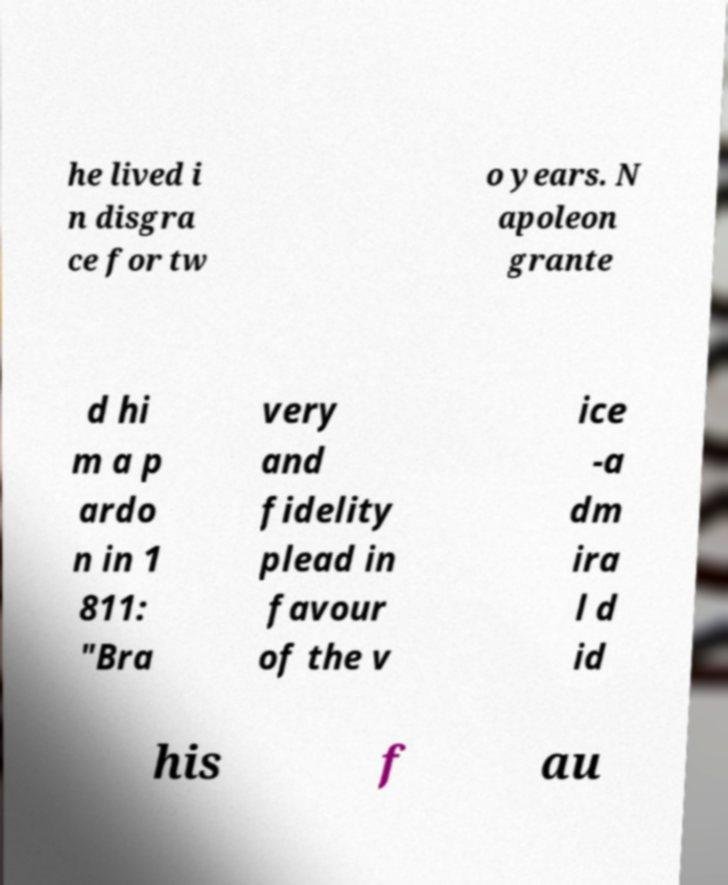Could you extract and type out the text from this image? he lived i n disgra ce for tw o years. N apoleon grante d hi m a p ardo n in 1 811: "Bra very and fidelity plead in favour of the v ice -a dm ira l d id his f au 